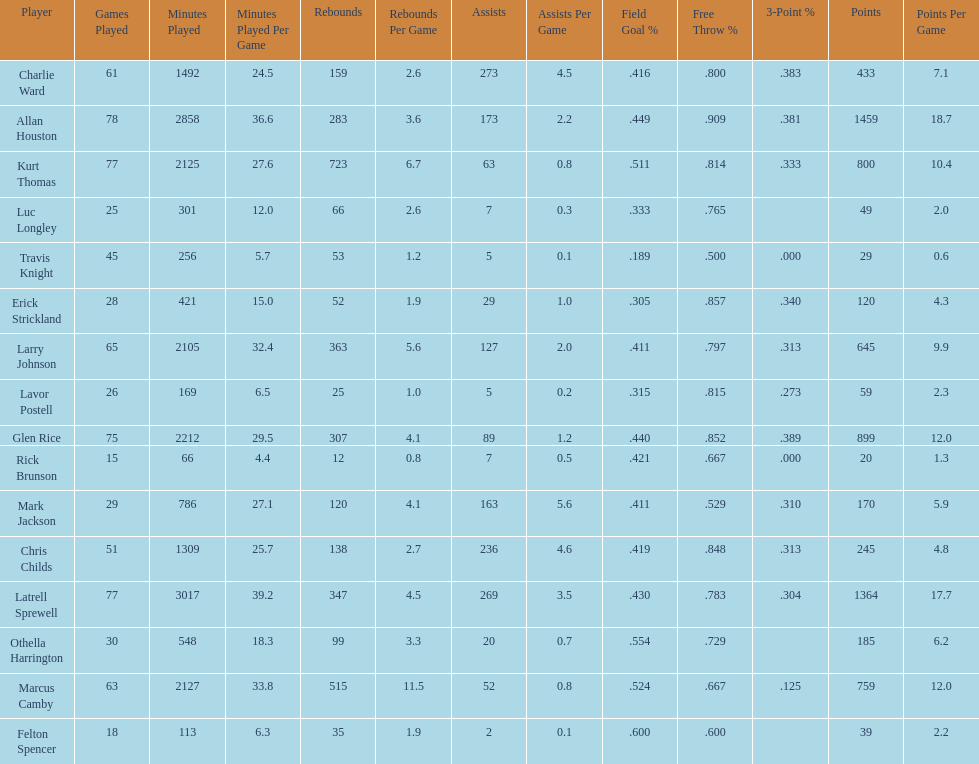How many more games did allan houston play than mark jackson? 49. 